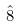Convert formula to latex. <formula><loc_0><loc_0><loc_500><loc_500>\hat { 8 }</formula> 